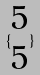Convert formula to latex. <formula><loc_0><loc_0><loc_500><loc_500>\{ \begin{matrix} 5 \\ 5 \end{matrix} \}</formula> 